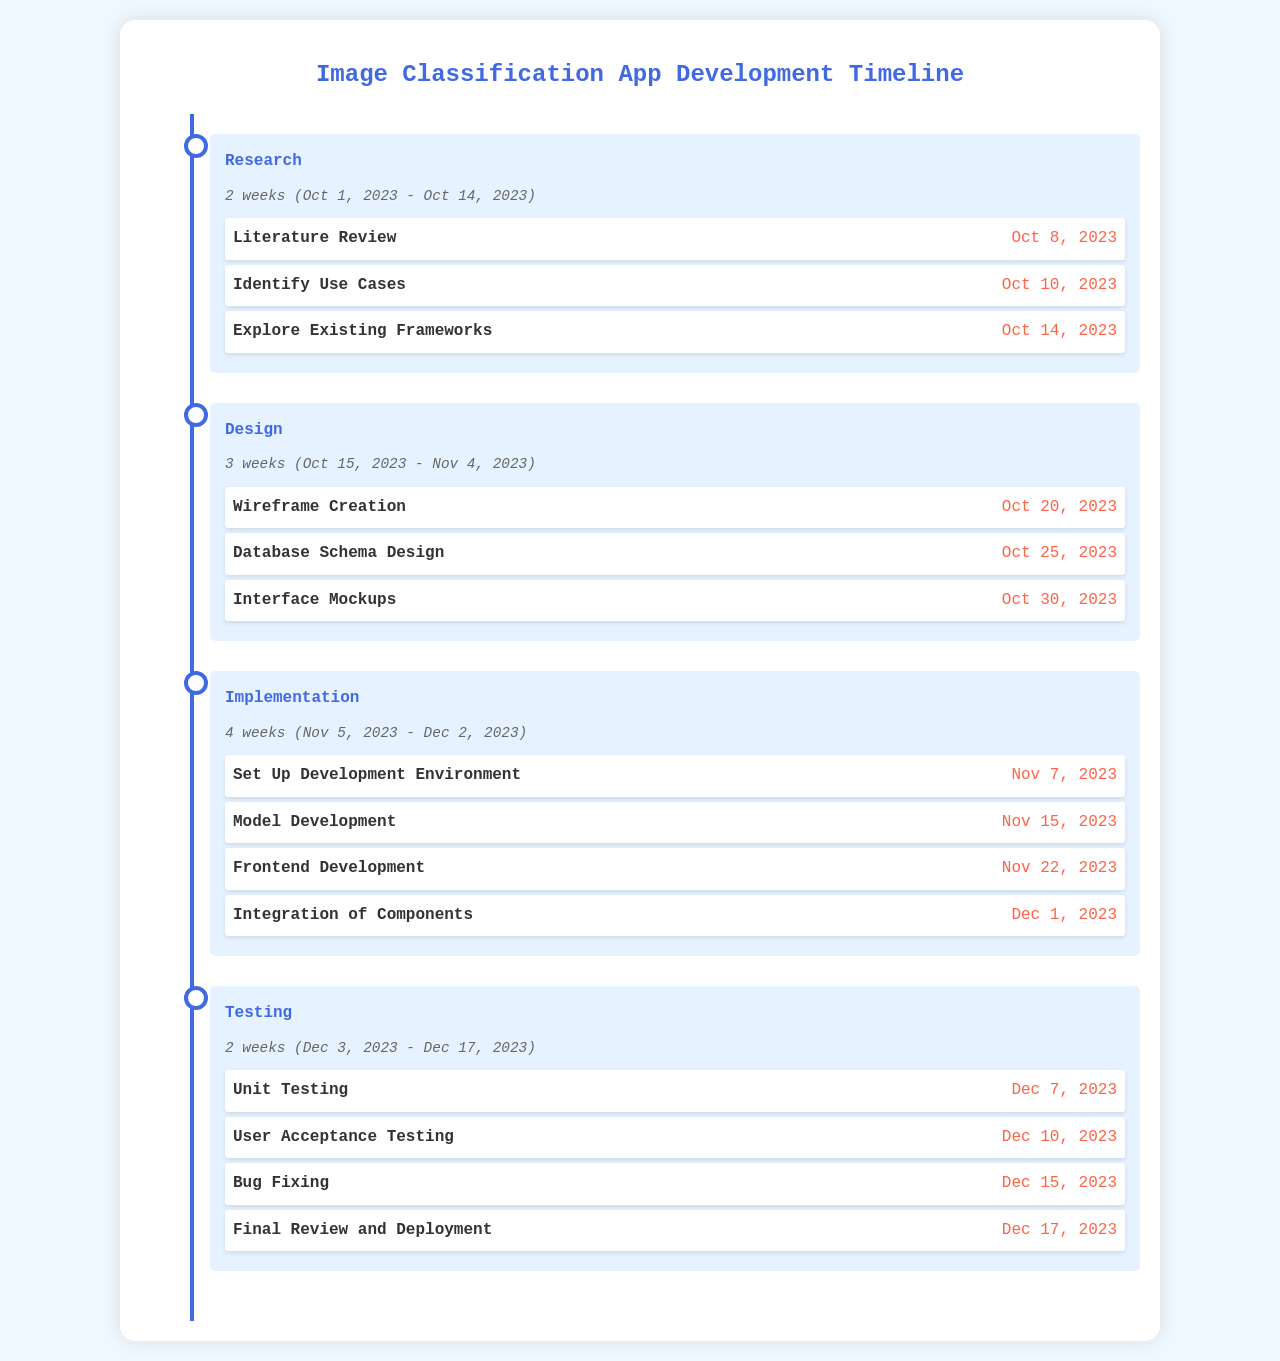What is the duration of the Research phase? The duration of the Research phase is specified as 2 weeks in the document.
Answer: 2 weeks When does the Design phase start? The start date of the Design phase is mentioned as October 15, 2023.
Answer: October 15, 2023 What is the deadline for the Wireframe Creation task? The deadline for the Wireframe Creation task is provided within the Design phase.
Answer: October 20, 2023 How many weeks is the Implementation phase? The Implementation phase spans over 4 weeks, according to the phase duration.
Answer: 4 weeks What type of testing is done after User Acceptance Testing? The testing done after User Acceptance Testing is Bug Fixing.
Answer: Bug Fixing Which phase has the task "Model Development"? The task "Model Development" is part of the Implementation phase as indicated in the document.
Answer: Implementation What is the final task listed in the Testing phase? The final task listed in the Testing phase is Final Review and Deployment.
Answer: Final Review and Deployment What is the end date of the Testing phase? The end date of the Testing phase is specified as December 17, 2023.
Answer: December 17, 2023 What is the primary focus of the document? The document focuses on the development timeline for an image classification app, outlining various phases and tasks.
Answer: Image Classification App Development Timeline 